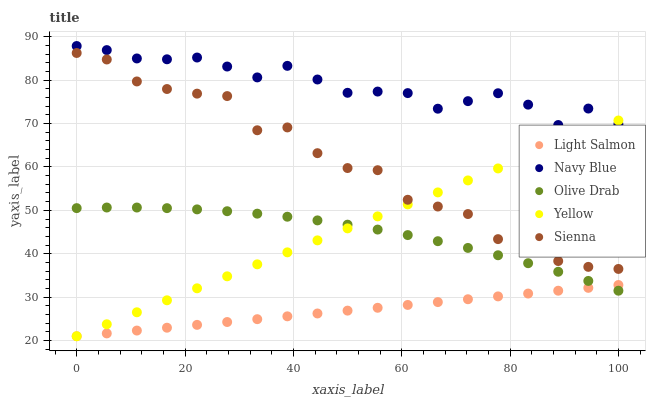Does Light Salmon have the minimum area under the curve?
Answer yes or no. Yes. Does Navy Blue have the maximum area under the curve?
Answer yes or no. Yes. Does Navy Blue have the minimum area under the curve?
Answer yes or no. No. Does Light Salmon have the maximum area under the curve?
Answer yes or no. No. Is Light Salmon the smoothest?
Answer yes or no. Yes. Is Sienna the roughest?
Answer yes or no. Yes. Is Navy Blue the smoothest?
Answer yes or no. No. Is Navy Blue the roughest?
Answer yes or no. No. Does Light Salmon have the lowest value?
Answer yes or no. Yes. Does Navy Blue have the lowest value?
Answer yes or no. No. Does Navy Blue have the highest value?
Answer yes or no. Yes. Does Light Salmon have the highest value?
Answer yes or no. No. Is Sienna less than Navy Blue?
Answer yes or no. Yes. Is Sienna greater than Olive Drab?
Answer yes or no. Yes. Does Olive Drab intersect Light Salmon?
Answer yes or no. Yes. Is Olive Drab less than Light Salmon?
Answer yes or no. No. Is Olive Drab greater than Light Salmon?
Answer yes or no. No. Does Sienna intersect Navy Blue?
Answer yes or no. No. 